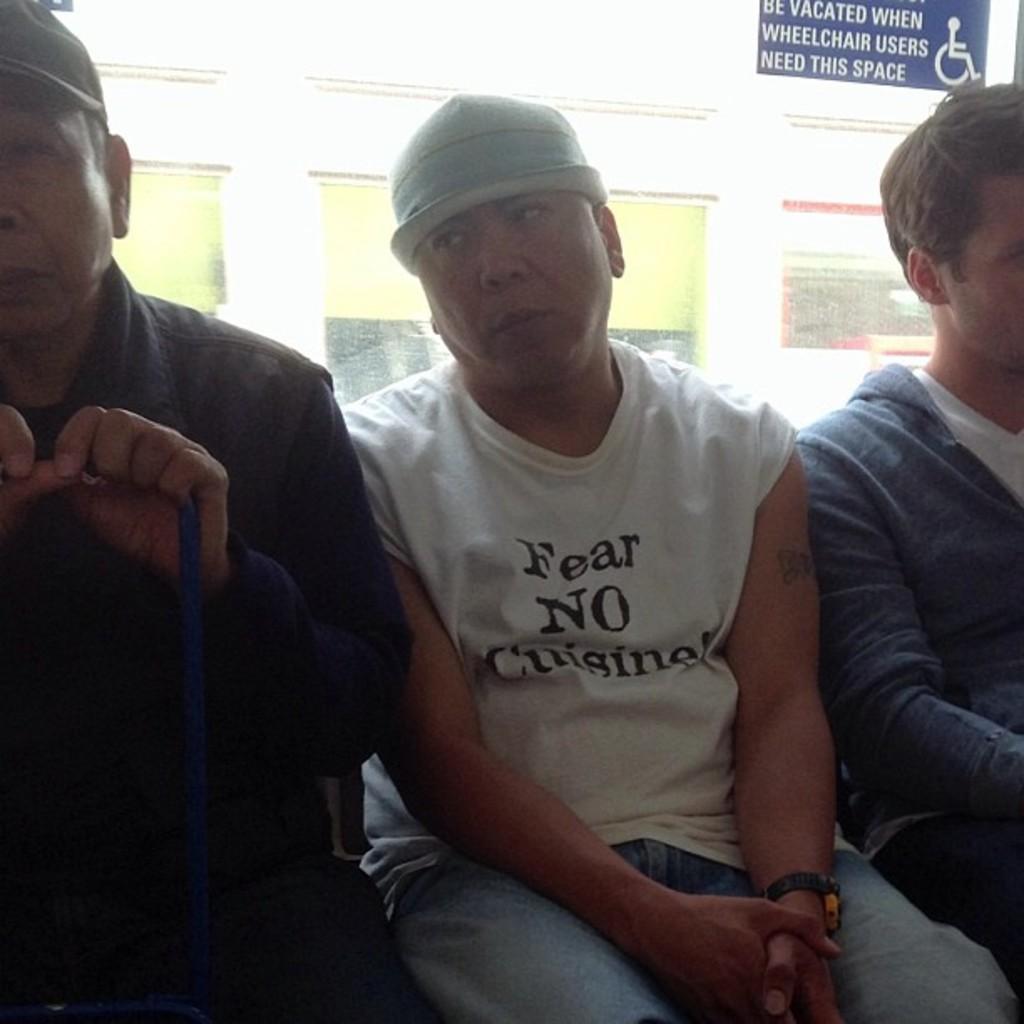Describe this image in one or two sentences. In this image I can see three persons are sitting. In the background I can see a wall, wall paintings and a board. This image is taken may be in a hall. 